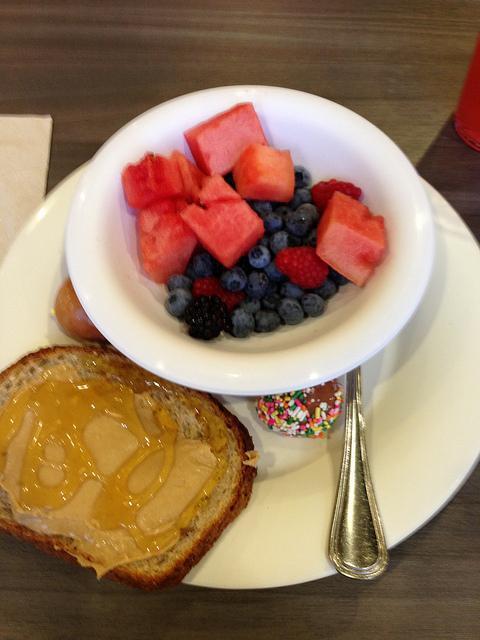How many fruits are there?
Give a very brief answer. 4. How many plates are in the picture?
Give a very brief answer. 1. How many watermelon slices are there?
Give a very brief answer. 6. How many types of fruit are on the plate?
Give a very brief answer. 4. How many dining tables are visible?
Give a very brief answer. 1. How many donuts do you count?
Give a very brief answer. 0. 